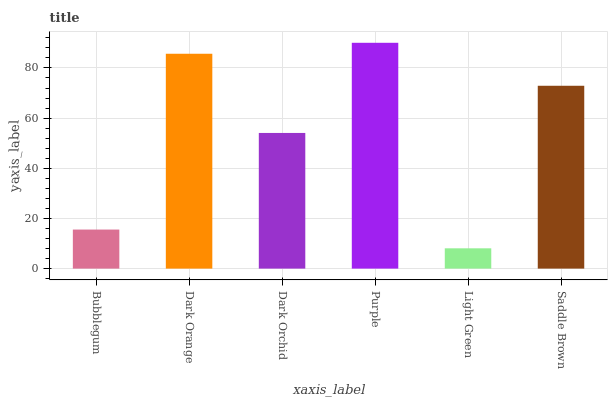Is Light Green the minimum?
Answer yes or no. Yes. Is Purple the maximum?
Answer yes or no. Yes. Is Dark Orange the minimum?
Answer yes or no. No. Is Dark Orange the maximum?
Answer yes or no. No. Is Dark Orange greater than Bubblegum?
Answer yes or no. Yes. Is Bubblegum less than Dark Orange?
Answer yes or no. Yes. Is Bubblegum greater than Dark Orange?
Answer yes or no. No. Is Dark Orange less than Bubblegum?
Answer yes or no. No. Is Saddle Brown the high median?
Answer yes or no. Yes. Is Dark Orchid the low median?
Answer yes or no. Yes. Is Dark Orange the high median?
Answer yes or no. No. Is Dark Orange the low median?
Answer yes or no. No. 